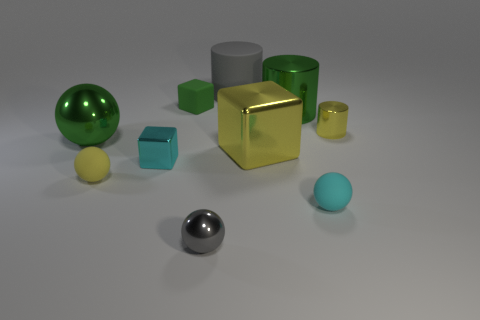Is the number of big spheres behind the yellow cylinder the same as the number of big yellow matte objects?
Your answer should be compact. Yes. What number of yellow matte objects have the same size as the gray metallic sphere?
Give a very brief answer. 1. What is the shape of the big object that is the same color as the tiny shiny cylinder?
Make the answer very short. Cube. Are any large brown metal balls visible?
Provide a short and direct response. No. There is a big green metal object behind the green sphere; is it the same shape as the object in front of the small cyan ball?
Ensure brevity in your answer.  No. How many large things are either rubber objects or cyan things?
Keep it short and to the point. 1. What shape is the yellow object that is made of the same material as the yellow cylinder?
Provide a succinct answer. Cube. Does the large yellow object have the same shape as the small gray object?
Your answer should be compact. No. The large metallic cube is what color?
Your answer should be very brief. Yellow. What number of objects are either matte things or small gray spheres?
Provide a succinct answer. 5. 